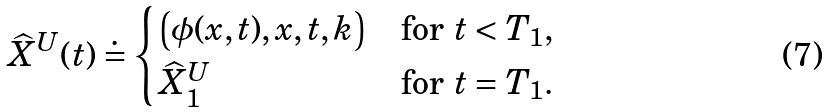Convert formula to latex. <formula><loc_0><loc_0><loc_500><loc_500>\widehat { X } ^ { U } ( t ) \doteq \begin{cases} \left ( \phi ( x , t ) , x , t , k \right ) & \text {for } t < T _ { 1 } , \\ \widehat { X } ^ { U } _ { 1 } & \text {for } t = T _ { 1 } . \end{cases}</formula> 